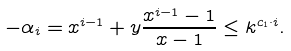<formula> <loc_0><loc_0><loc_500><loc_500>- \alpha _ { i } = x ^ { i - 1 } + y \frac { x ^ { i - 1 } - 1 } { x - 1 } \leq k ^ { c _ { 1 } \cdot i } .</formula> 